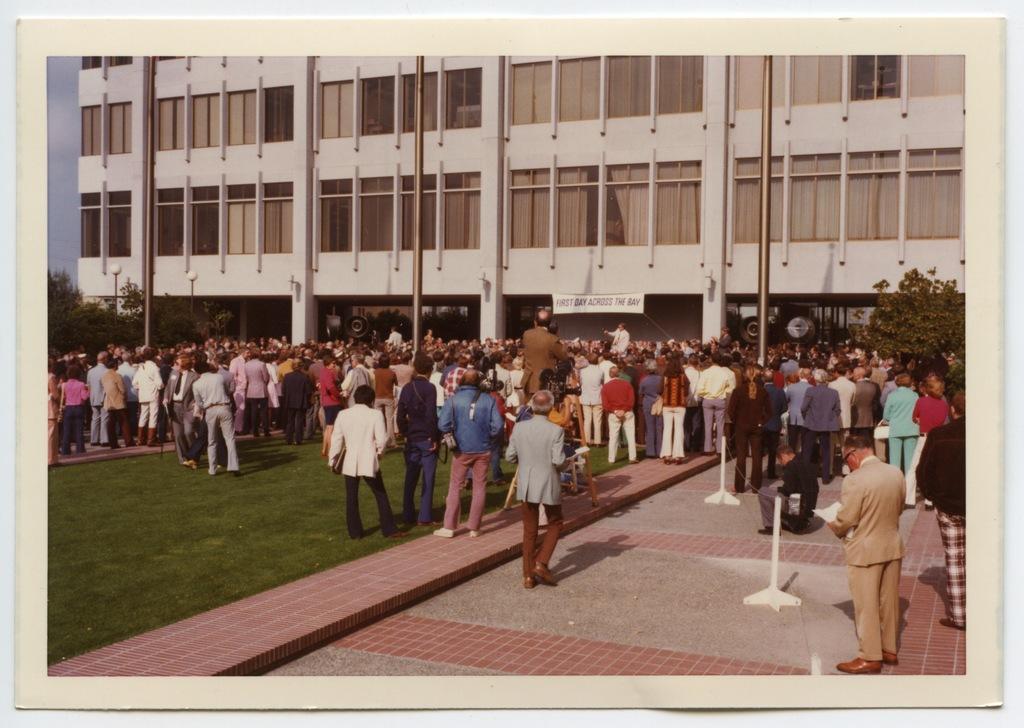Describe this image in one or two sentences. At the bottom of the image there is a floor and also there is a ground with grass. There are many people standing. On the right side of the image there are poles. In front of the people there are trees and also there are poles with lamps. There is a building with walls, glass windows, pillars and poster. 